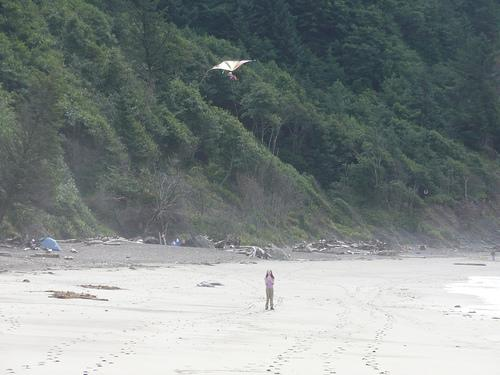What flutters just beneath the main body of this kite? tail 